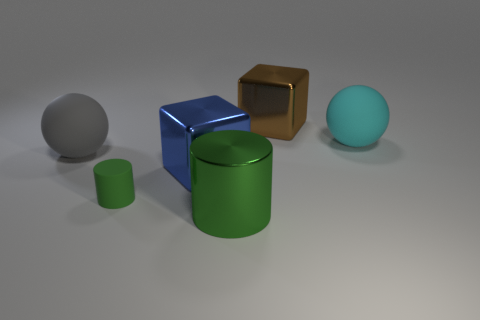Add 3 small cylinders. How many objects exist? 9 Subtract all balls. How many objects are left? 4 Add 4 blue things. How many blue things exist? 5 Subtract 0 red blocks. How many objects are left? 6 Subtract all big yellow spheres. Subtract all tiny green rubber cylinders. How many objects are left? 5 Add 5 large cyan matte things. How many large cyan matte things are left? 6 